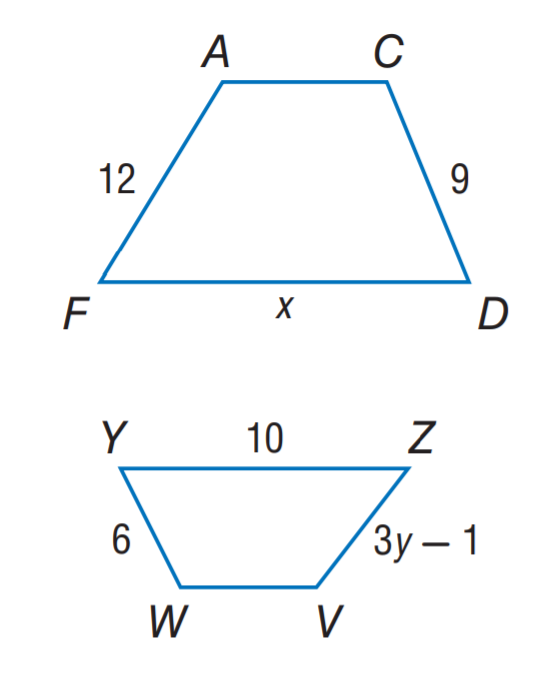Question: A C D F \sim V W Y Z. Find x.
Choices:
A. 9
B. 10
C. 12
D. 15
Answer with the letter. Answer: D Question: A C D F \sim V W Y Z. Find y.
Choices:
A. 3
B. 5
C. 6
D. 9
Answer with the letter. Answer: A 